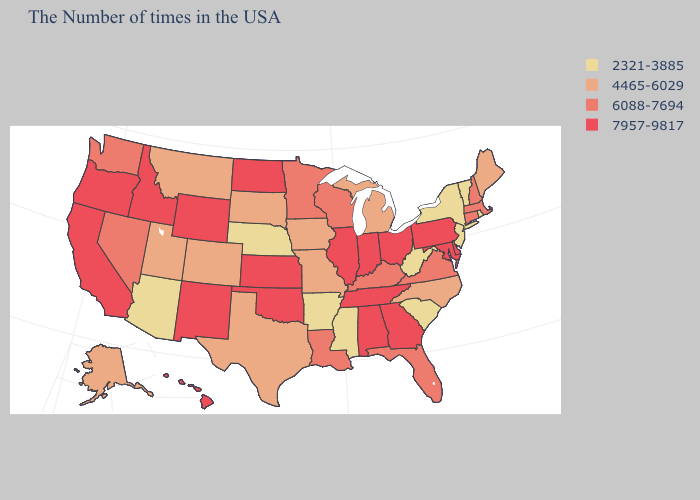Name the states that have a value in the range 7957-9817?
Write a very short answer. Delaware, Maryland, Pennsylvania, Ohio, Georgia, Indiana, Alabama, Tennessee, Illinois, Kansas, Oklahoma, North Dakota, Wyoming, New Mexico, Idaho, California, Oregon, Hawaii. Name the states that have a value in the range 7957-9817?
Answer briefly. Delaware, Maryland, Pennsylvania, Ohio, Georgia, Indiana, Alabama, Tennessee, Illinois, Kansas, Oklahoma, North Dakota, Wyoming, New Mexico, Idaho, California, Oregon, Hawaii. What is the lowest value in the USA?
Write a very short answer. 2321-3885. Which states have the lowest value in the Northeast?
Quick response, please. Rhode Island, Vermont, New York, New Jersey. Name the states that have a value in the range 2321-3885?
Short answer required. Rhode Island, Vermont, New York, New Jersey, South Carolina, West Virginia, Mississippi, Arkansas, Nebraska, Arizona. Name the states that have a value in the range 4465-6029?
Answer briefly. Maine, North Carolina, Michigan, Missouri, Iowa, Texas, South Dakota, Colorado, Utah, Montana, Alaska. What is the value of Louisiana?
Concise answer only. 6088-7694. What is the value of Tennessee?
Be succinct. 7957-9817. Does North Dakota have a higher value than Connecticut?
Be succinct. Yes. What is the value of Ohio?
Be succinct. 7957-9817. Name the states that have a value in the range 2321-3885?
Concise answer only. Rhode Island, Vermont, New York, New Jersey, South Carolina, West Virginia, Mississippi, Arkansas, Nebraska, Arizona. What is the value of New Mexico?
Quick response, please. 7957-9817. Does Arizona have a lower value than Colorado?
Give a very brief answer. Yes. What is the value of Vermont?
Quick response, please. 2321-3885. Name the states that have a value in the range 2321-3885?
Concise answer only. Rhode Island, Vermont, New York, New Jersey, South Carolina, West Virginia, Mississippi, Arkansas, Nebraska, Arizona. 